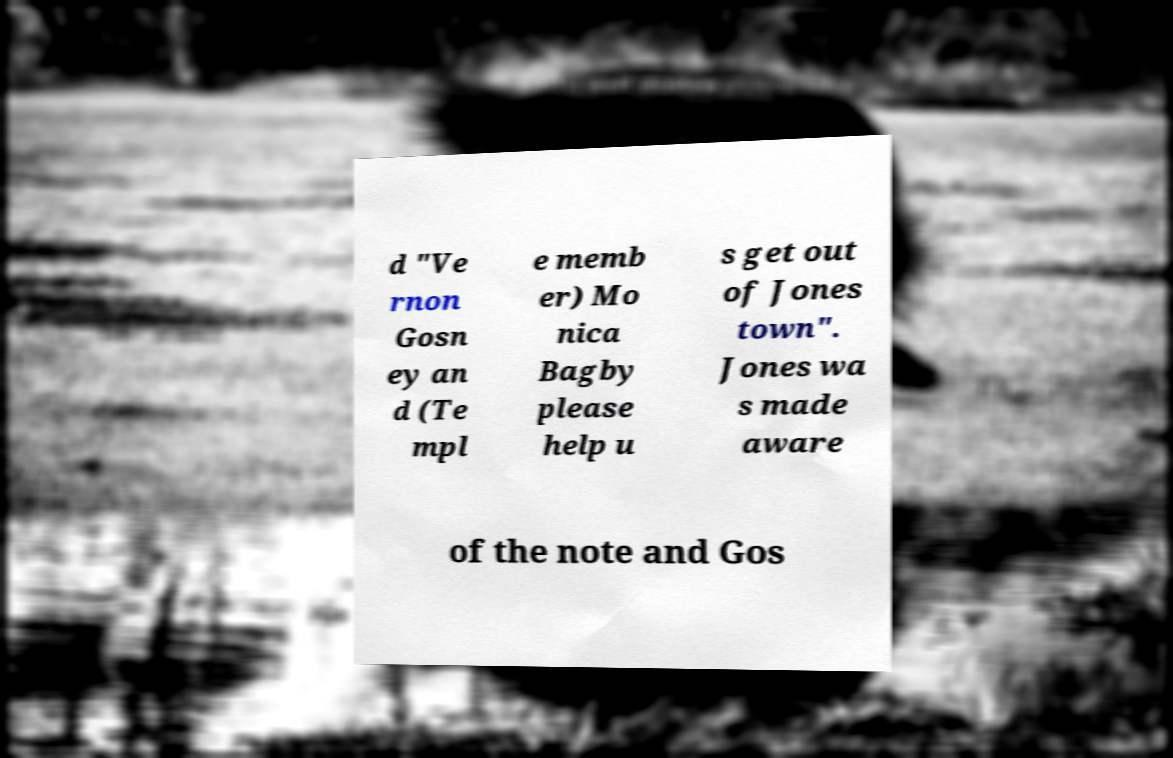Could you extract and type out the text from this image? d "Ve rnon Gosn ey an d (Te mpl e memb er) Mo nica Bagby please help u s get out of Jones town". Jones wa s made aware of the note and Gos 